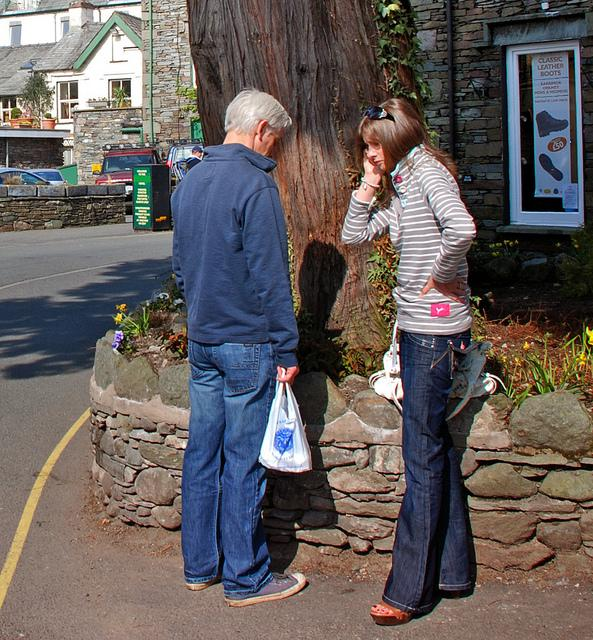What does the woman have in her right hand?

Choices:
A) charger
B) coins
C) phone
D) bible phone 